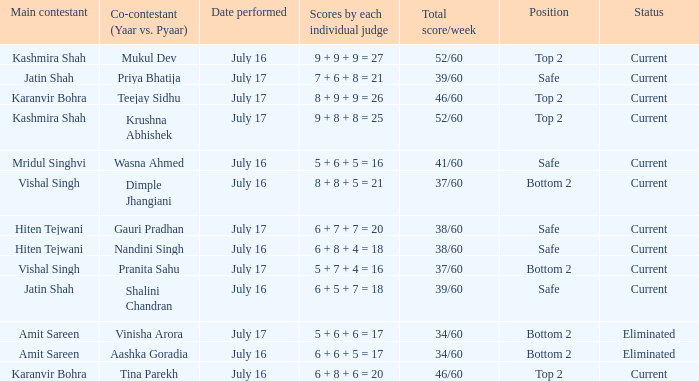On which date did jatin shah and shalini chandran perform? July 16. 